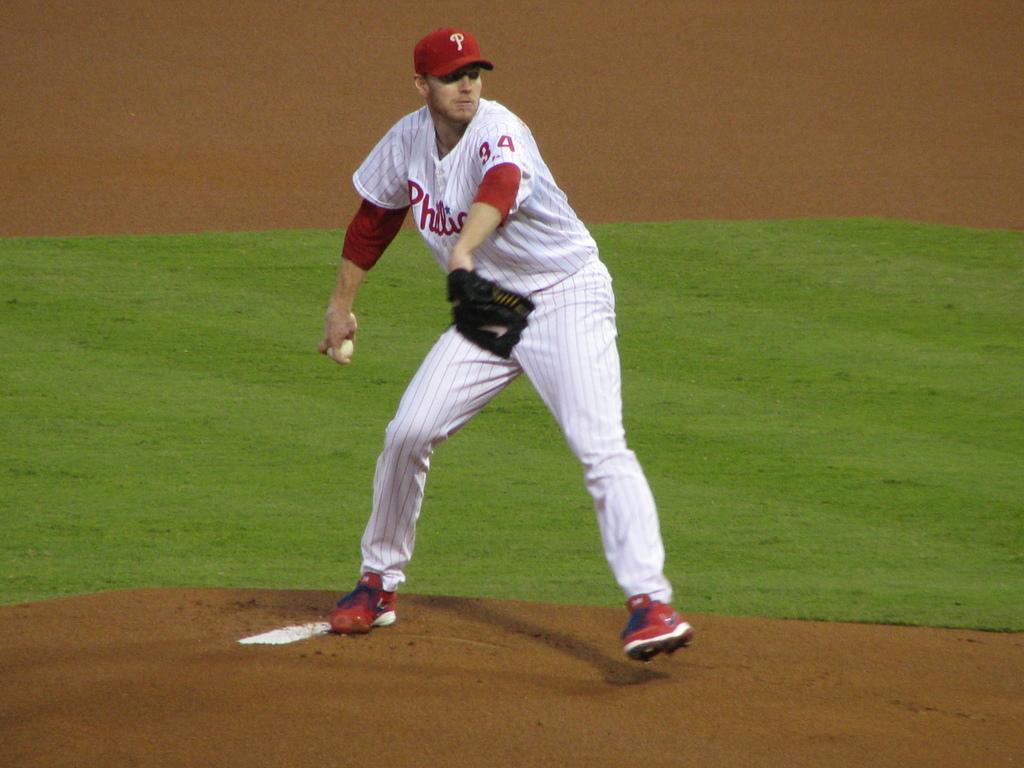Provide a one-sentence caption for the provided image. The baseball player is wearing jersey number 44. 